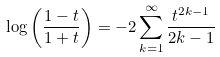<formula> <loc_0><loc_0><loc_500><loc_500>& \log \left ( \frac { 1 - t } { 1 + t } \right ) = - 2 \sum _ { k = 1 } ^ { \infty } \frac { t ^ { 2 k - 1 } } { 2 k - 1 }</formula> 